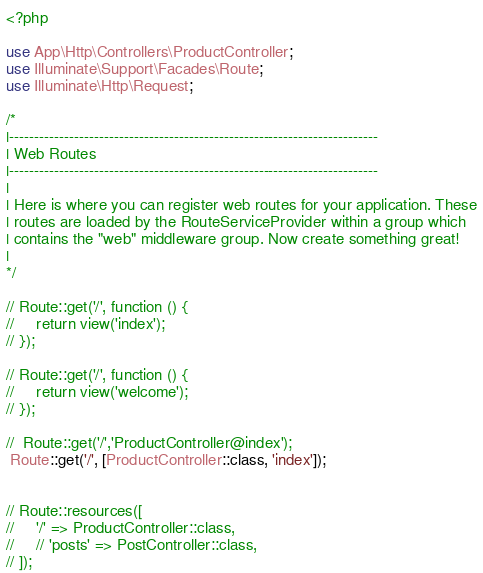<code> <loc_0><loc_0><loc_500><loc_500><_PHP_><?php

use App\Http\Controllers\ProductController;
use Illuminate\Support\Facades\Route;
use Illuminate\Http\Request;

/*
|--------------------------------------------------------------------------
| Web Routes
|--------------------------------------------------------------------------
|
| Here is where you can register web routes for your application. These
| routes are loaded by the RouteServiceProvider within a group which
| contains the "web" middleware group. Now create something great!
|
*/

// Route::get('/', function () {
//     return view('index');
// });

// Route::get('/', function () {
//     return view('welcome');
// });

//  Route::get('/','ProductController@index');
 Route::get('/', [ProductController::class, 'index']);


// Route::resources([
//     '/' => ProductController::class,
//     // 'posts' => PostController::class,
// ]);
</code> 